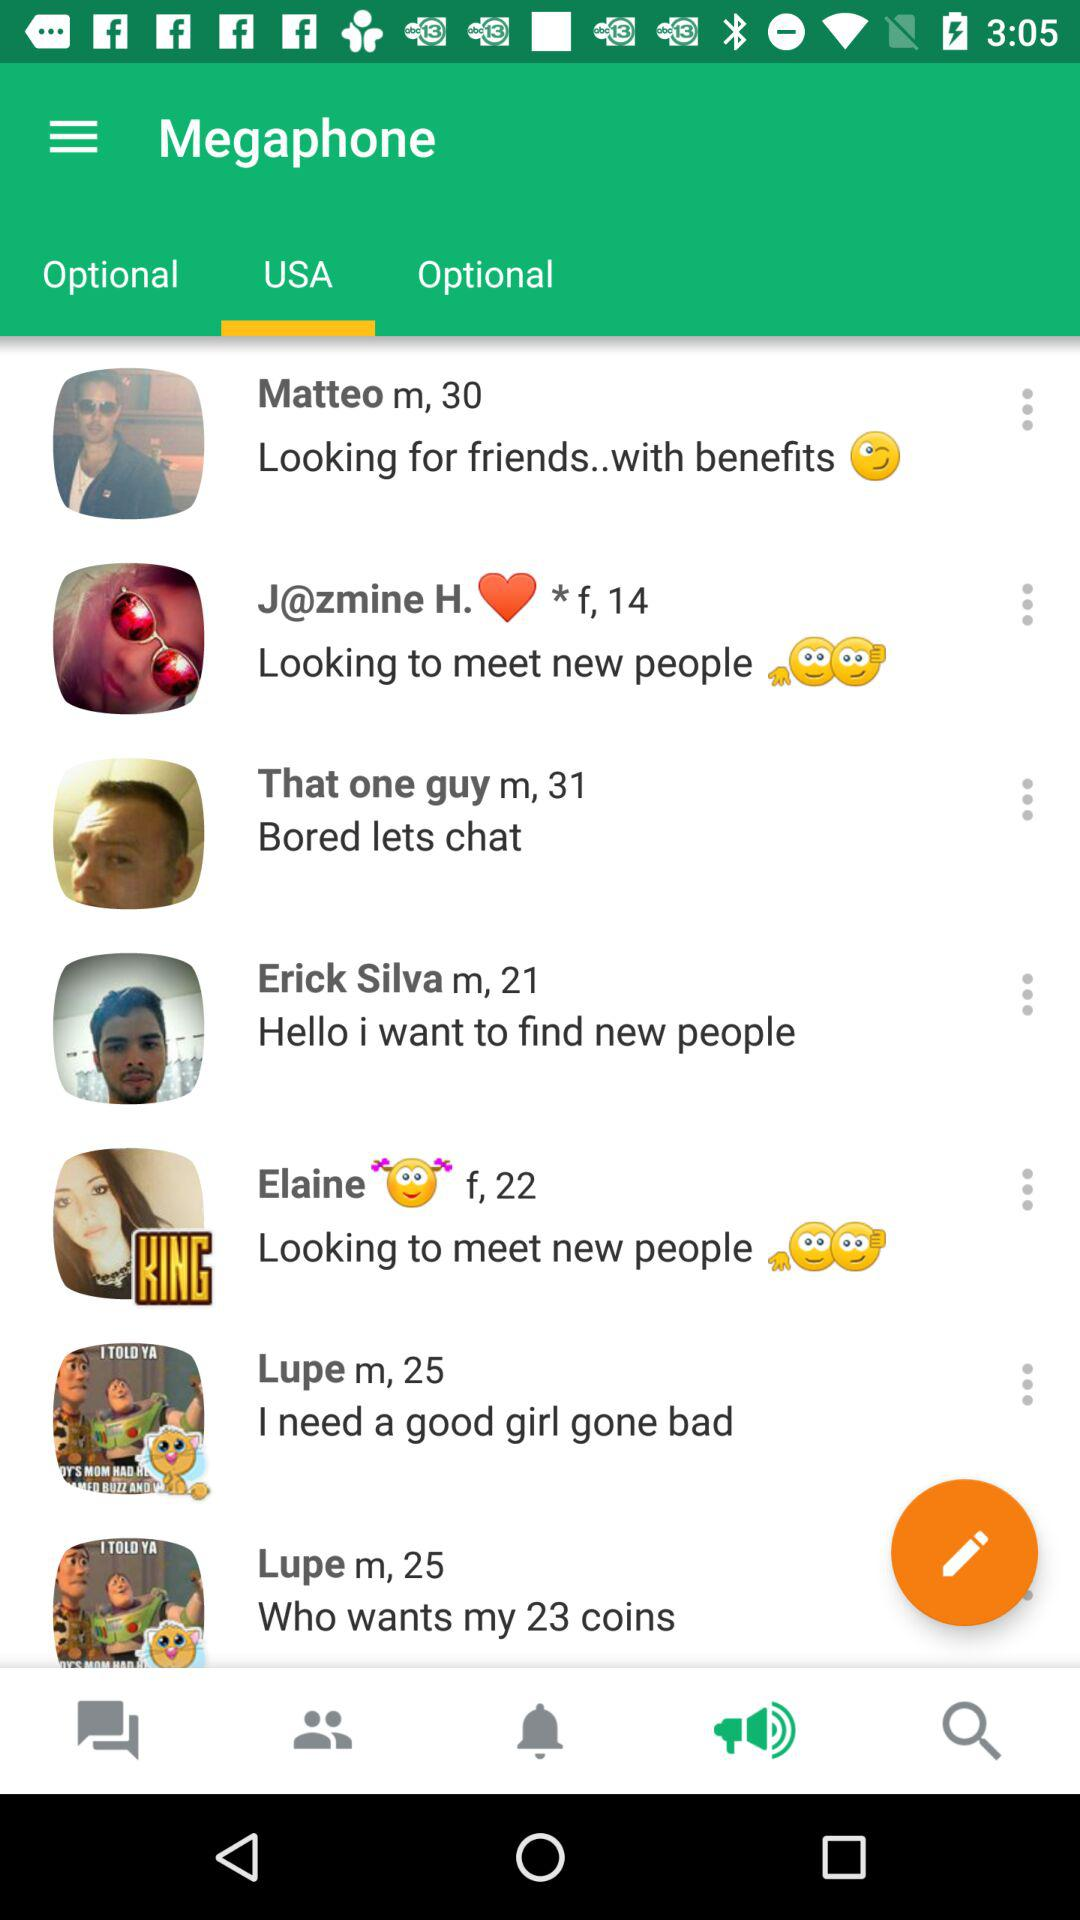What is Matteo looking for? Matteo is looking for friends with benefits. 